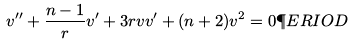Convert formula to latex. <formula><loc_0><loc_0><loc_500><loc_500>v ^ { \prime \prime } + \frac { n - 1 } { r } v ^ { \prime } + 3 r v v ^ { \prime } + ( n + 2 ) v ^ { 2 } = 0 \P E R I O D</formula> 